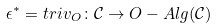<formula> <loc_0><loc_0><loc_500><loc_500>\epsilon ^ { * } = t r i v _ { O } \colon \mathcal { C } \rightarrow O - A l g ( \mathcal { C } )</formula> 